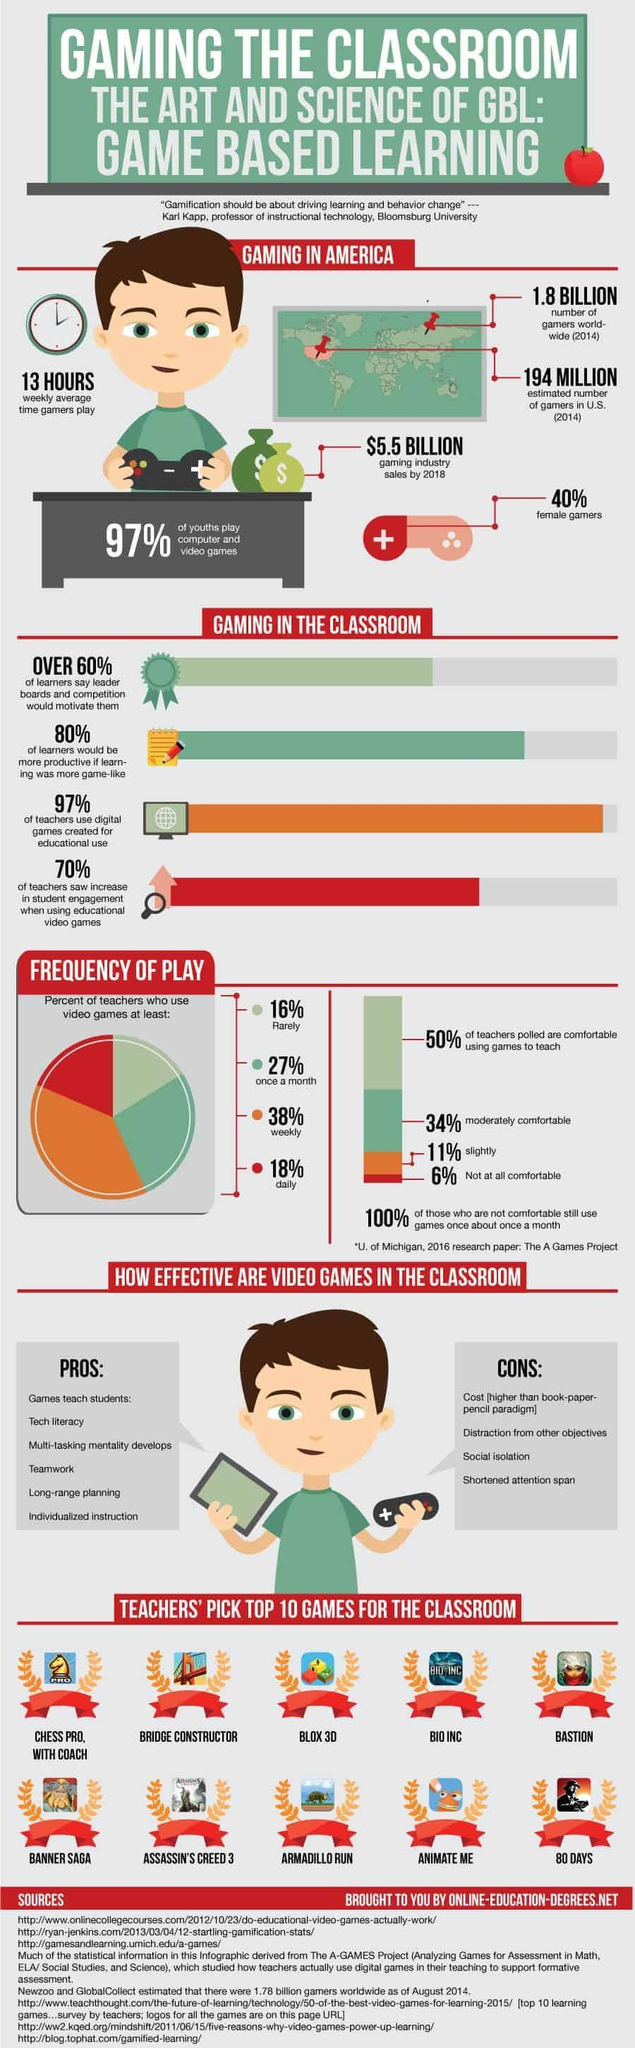What percentage of teachers are not at all comfortable to use games for teaching in U.S?
Answer the question with a short phrase. 6% What is the estimated number of gamers in U.S. in 2014? 194 MILLION What percentage of youths do not play computer & video games in U.S.? 3% What percentage of teachers use video games rarely in U.S? 16% What percentage of gamers are males in America? 60% What percentage of teachers use video games at least once in a month in U.S.? 27% What percentage of teachers in America do not use digital games created for educational use? 3% What percentage of teachers use video games weekly in U.S.? 38% 